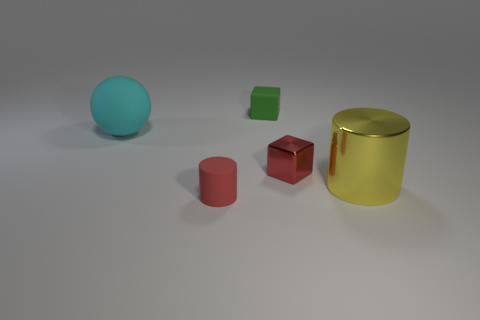How many things are both in front of the tiny metal object and to the right of the green matte thing?
Your answer should be compact. 1. What number of objects are either tiny red shiny blocks or small objects that are in front of the big sphere?
Make the answer very short. 2. What is the size of the green object that is made of the same material as the small cylinder?
Offer a terse response. Small. There is a big thing behind the tiny block that is in front of the big matte thing; what shape is it?
Offer a terse response. Sphere. How many green things are metallic blocks or matte cubes?
Keep it short and to the point. 1. Are there any small red things in front of the cylinder that is right of the tiny red thing that is in front of the yellow thing?
Your answer should be compact. Yes. There is a object that is the same color as the rubber cylinder; what shape is it?
Your answer should be compact. Cube. What number of small objects are matte cubes or yellow metallic cylinders?
Provide a succinct answer. 1. Do the red thing right of the green cube and the large matte object have the same shape?
Make the answer very short. No. Are there fewer tiny green matte things than large red things?
Your answer should be very brief. No. 